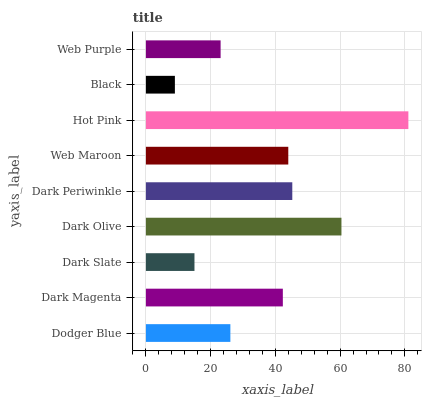Is Black the minimum?
Answer yes or no. Yes. Is Hot Pink the maximum?
Answer yes or no. Yes. Is Dark Magenta the minimum?
Answer yes or no. No. Is Dark Magenta the maximum?
Answer yes or no. No. Is Dark Magenta greater than Dodger Blue?
Answer yes or no. Yes. Is Dodger Blue less than Dark Magenta?
Answer yes or no. Yes. Is Dodger Blue greater than Dark Magenta?
Answer yes or no. No. Is Dark Magenta less than Dodger Blue?
Answer yes or no. No. Is Dark Magenta the high median?
Answer yes or no. Yes. Is Dark Magenta the low median?
Answer yes or no. Yes. Is Dark Slate the high median?
Answer yes or no. No. Is Black the low median?
Answer yes or no. No. 